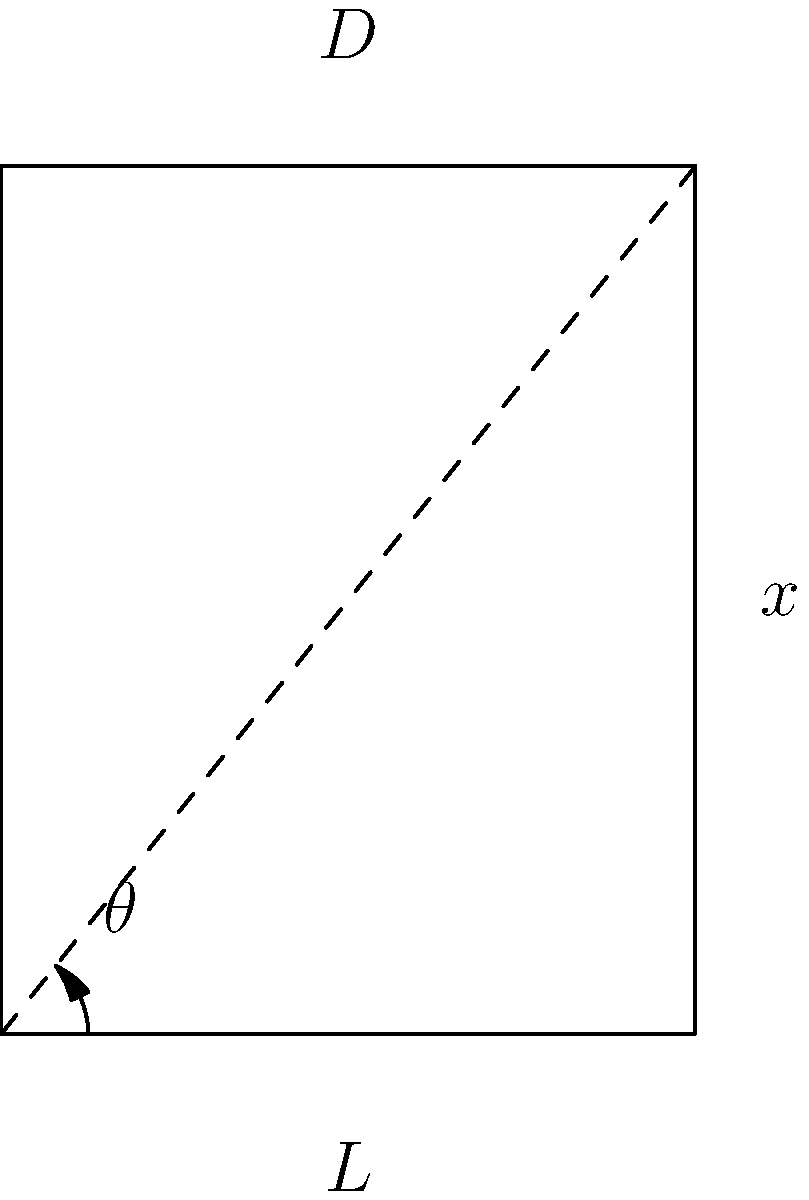In a traditional Native American hunting bow, the bow string is pulled back a distance $D$ from its resting position. The length of the bow arm is $L$, and the angle between the bow arm and the drawn string is $\theta$. If the arrow is released from this position, what is the maximum horizontal distance $x$ the arrow can travel, assuming no air resistance and neglecting the effects of gravity? To solve this problem, we'll follow these steps:

1) First, we need to understand that the maximum horizontal distance will be achieved when the arrow is released at a 45-degree angle to the horizontal.

2) The initial velocity of the arrow ($v_0$) is key to determining its range. This velocity is related to the energy stored in the bow.

3) The energy stored in the bow is proportional to the draw force and the draw length. In a simplified model, we can assume the bow behaves like a spring, where:

   $E = \frac{1}{2}kD^2$

   where $k$ is the spring constant of the bow and $D$ is the draw length.

4) This energy is converted to kinetic energy of the arrow:

   $E = \frac{1}{2}mv_0^2$

   where $m$ is the mass of the arrow.

5) Equating these energies:

   $\frac{1}{2}kD^2 = \frac{1}{2}mv_0^2$

6) Solving for $v_0$:

   $v_0 = D\sqrt{\frac{k}{m}}$

7) The range of a projectile launched at 45 degrees is given by:

   $x = \frac{v_0^2}{g}$

   where $g$ is the acceleration due to gravity.

8) Substituting our expression for $v_0$:

   $x = \frac{D^2k}{mg}$

9) The draw length $D$ can be expressed in terms of $L$ and $\theta$:

   $D = 2L\sin(\frac{\theta}{2})$

10) Substituting this into our range equation:

    $x = \frac{4L^2\sin^2(\frac{\theta}{2})k}{mg}$

This is the maximum horizontal distance the arrow can travel, expressed in terms of the bow's characteristics.
Answer: $x = \frac{4L^2\sin^2(\frac{\theta}{2})k}{mg}$ 